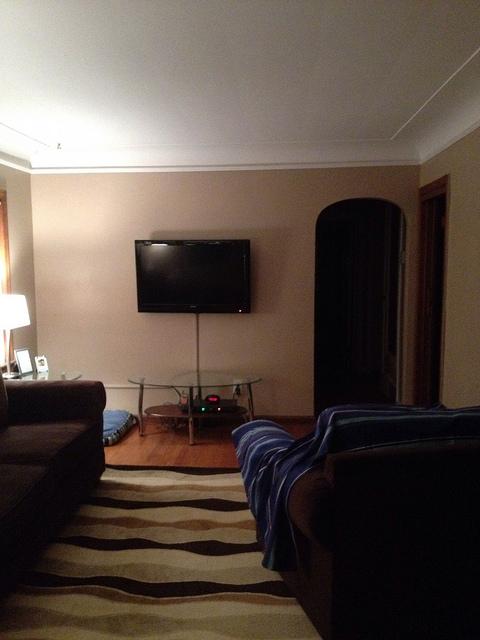Is the shape of this room conventional?
Short answer required. Yes. What is the style of chair shown on the left?
Quick response, please. Couch. Which room is this?
Be succinct. Living room. How many people are in the room?
Be succinct. 0. Is the TV on?
Give a very brief answer. No. What size screen does this TV have?
Keep it brief. 32 inch. What is above the glass table on the wall?
Write a very short answer. Tv. What kind of building is the room in?
Write a very short answer. Hotel. 